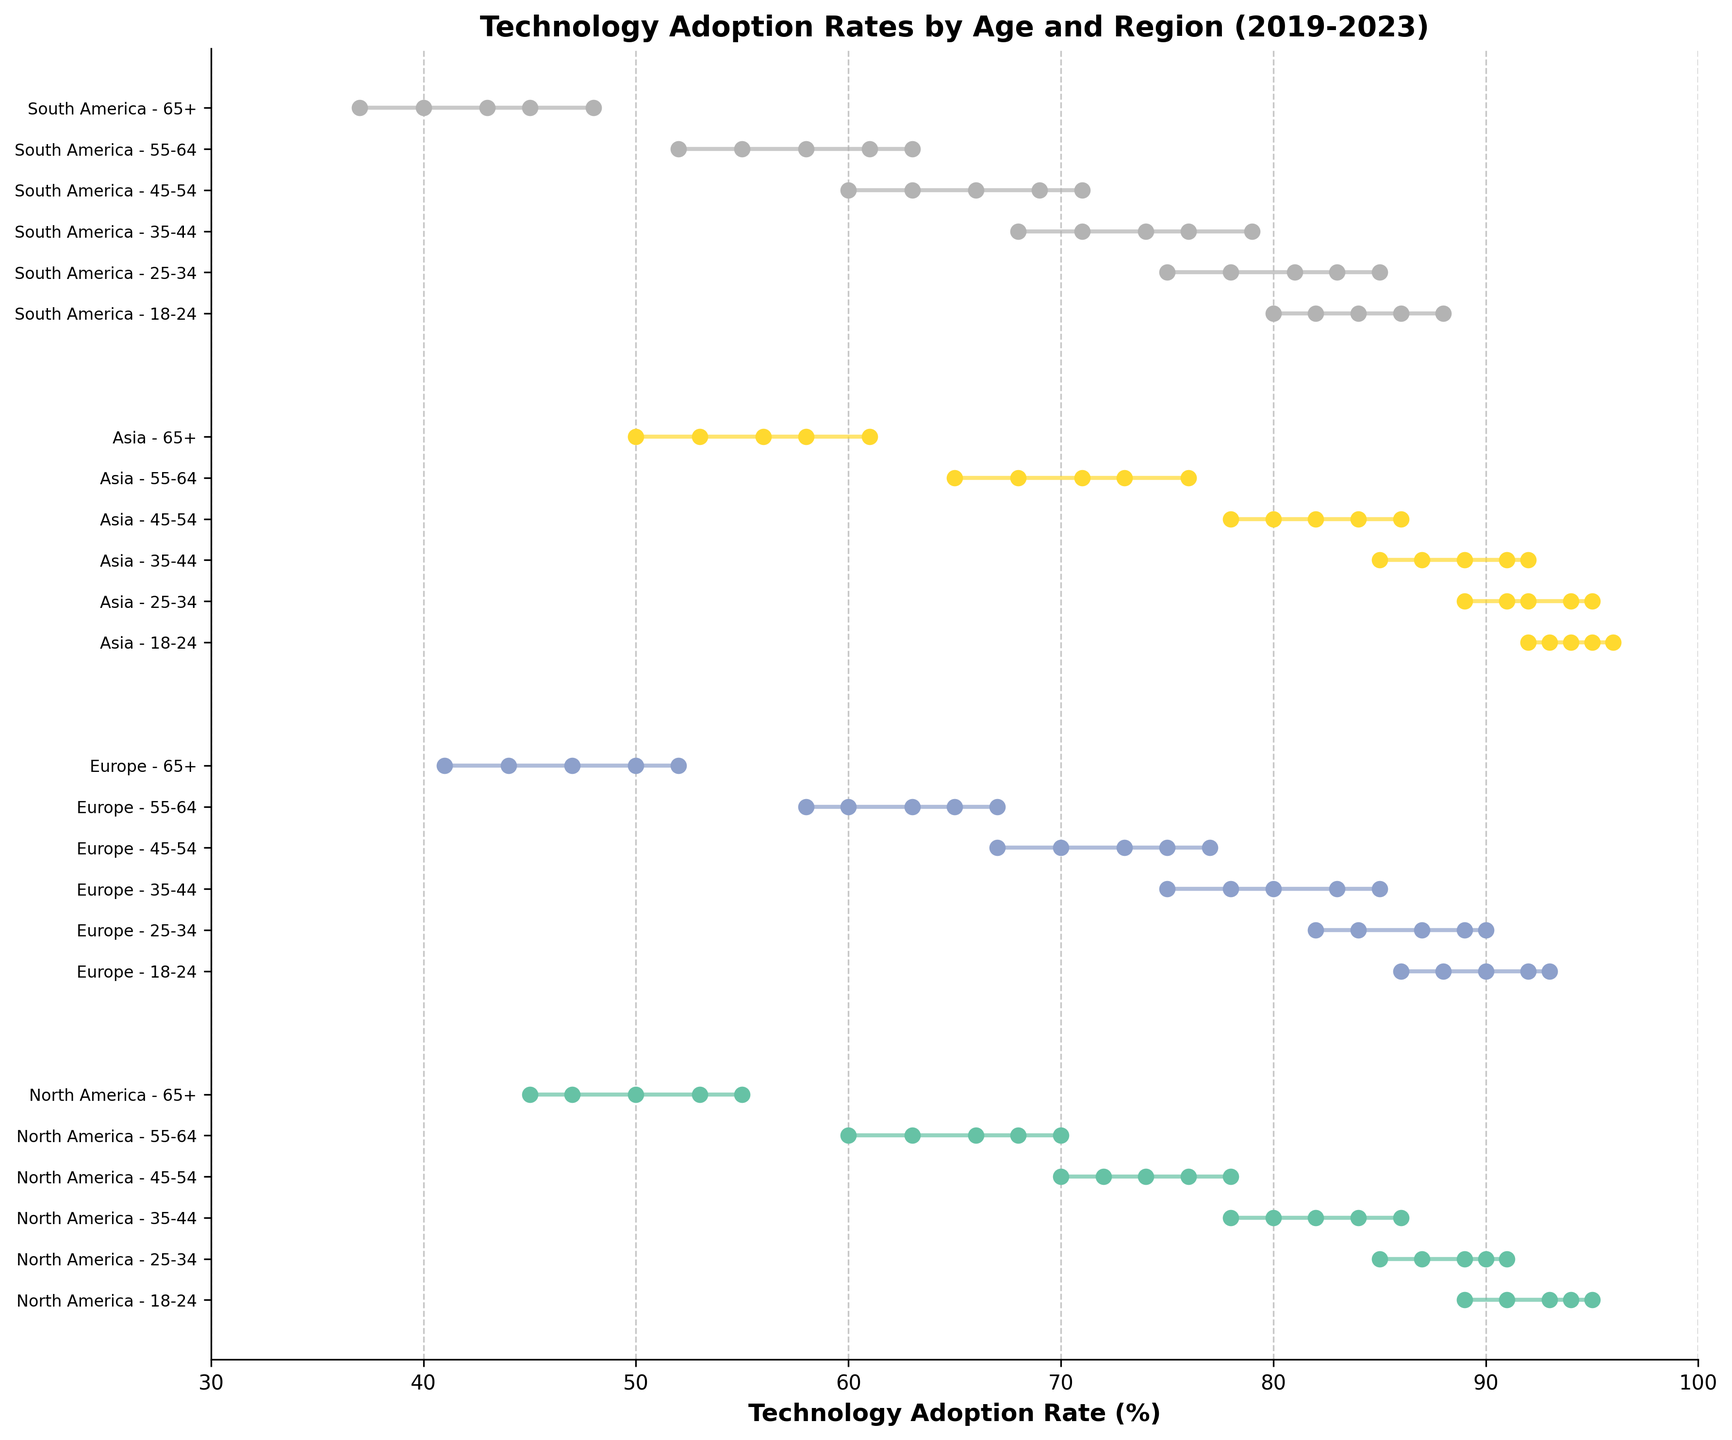What is the title of the plot? The title of the plot is shown at the top and it reads "Technology Adoption Rates by Age and Region (2019-2023)"
Answer: Technology Adoption Rates by Age and Region (2019-2023) What is the range of technology adoption rates for North America age group 25-34? The plot shows the ranges for each age group using horizontal lines. For North America age group 25-34, the range is from the lowest point which is 85% in 2019 to the highest point which is 91% in 2023.
Answer: 85% to 91% Which age group in Europe had the lowest technology adoption rate in 2019? By looking at the plot and focusing on Europe in 2019, the age group 65+ had the lowest adoption rate at 41%.
Answer: 65+ What is the overall pattern observed in technology adoption rates across all age groups and regions from 2019 to 2023? The plot shows that the technology adoption rates increase over time for all age groups across all regions, showing an upward trend from 2019 to 2023.
Answer: Increasing trend Compare the technology adoption rates of the age group 18-24 in North America and Asia in 2023. Which region has a higher rate? In the plot, for the age group 18-24 in 2023, North America has an adoption rate of 95% while Asia has a slightly higher rate of 96%.
Answer: Asia Which region shows the highest increase in technology adoption rates for the age group 55-64 from 2019 to 2023? By calculating the difference between the rates of 2023 and 2019 for the age group 55-64 in each region, Asia shows the highest increase. Starting from 65% in 2019 to 76% in 2023, the increase is 11%.
Answer: Asia Which age group in South America had the highest technology adoption rate in 2021? Observing the 2021 data points for South America, the age group 18-24 had the highest adoption rate at 84%.
Answer: 18-24 How does the technology adoption rate for the age group 35-44 in Europe in 2023 compare to the same age group in South America in the same year? In the plot, for the age group 35-44 in 2023, Europe has an adoption rate of 85% while South America has a rate of 79%. Europe has a higher rate.
Answer: Europe What is the approximate average increase in technology adoption rates for the age group 45-54 in North America over the 5-year period? The rates from 2019 to 2023 for North America age group 45-54 are 70%, 72%, 74%, 76%, and 78%. The total increase from 2019 to 2023 is 8% (78% - 70%). Over 5 years, the average increase per year is 8% / 5 = 1.6%
Answer: 1.6% 